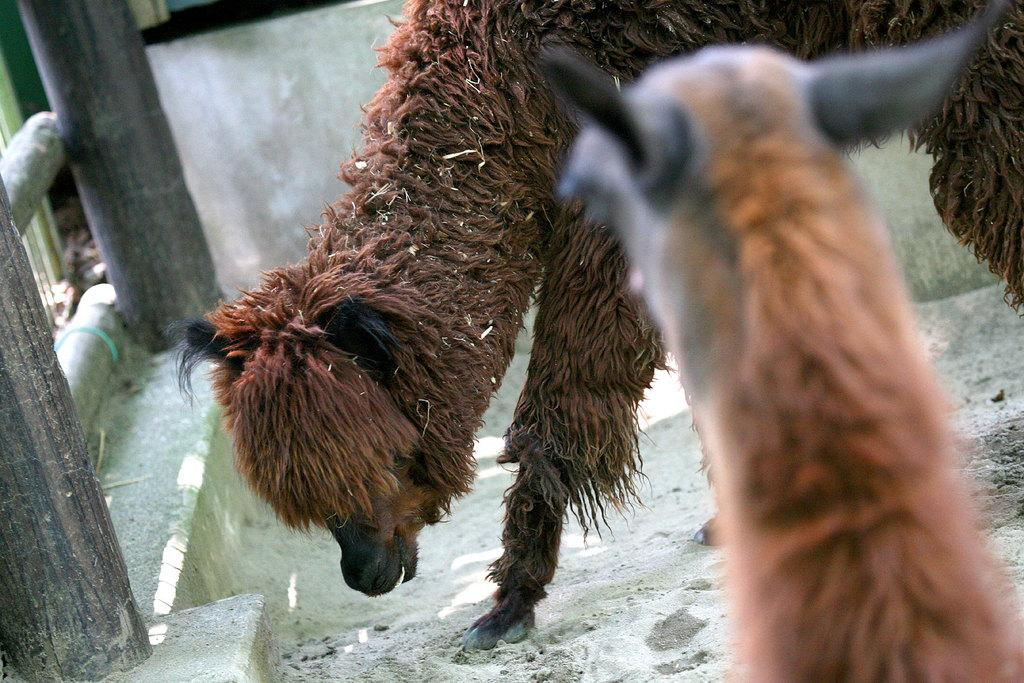How many animals are present in the image? There are two animals in the image. What else can be seen in the image besides the animals? There are poles in the image. What is the background of the image? The background of the image resembles a wall. What is the girl's reaction to the animals in the image? There is no girl present in the image, so it is not possible to determine her reaction. 